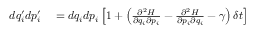Convert formula to latex. <formula><loc_0><loc_0><loc_500><loc_500>\begin{array} { r l } { d q _ { i } ^ { \prime } d p _ { i } ^ { \prime } } & = d q _ { i } d p _ { i } \left [ 1 + \left ( { \frac { \partial ^ { 2 } H } { \partial q _ { i } \partial p _ { i } } } - { \frac { \partial ^ { 2 } H } { \partial p _ { i } \partial q _ { i } } } - \gamma \right ) \delta t \right ] } \end{array}</formula> 